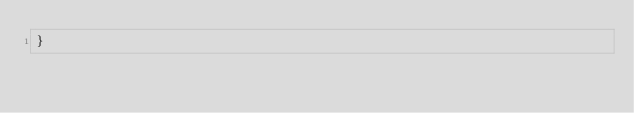Convert code to text. <code><loc_0><loc_0><loc_500><loc_500><_Rust_>}
</code> 